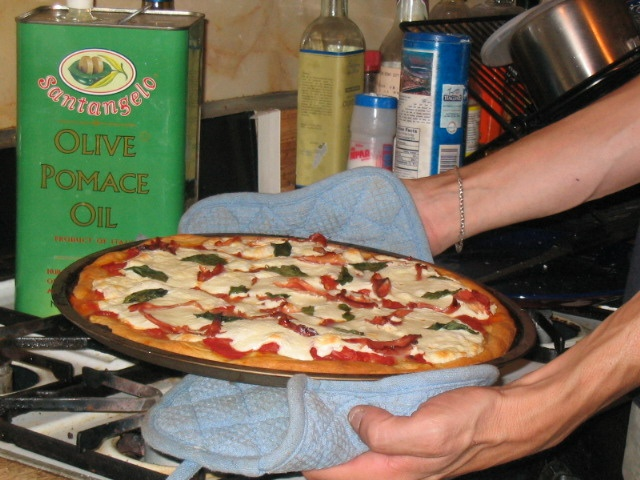Describe the objects in this image and their specific colors. I can see pizza in tan and brown tones, people in olive and salmon tones, oven in olive, black, darkgray, and gray tones, oven in olive, black, and gray tones, and bottle in olive and gray tones in this image. 